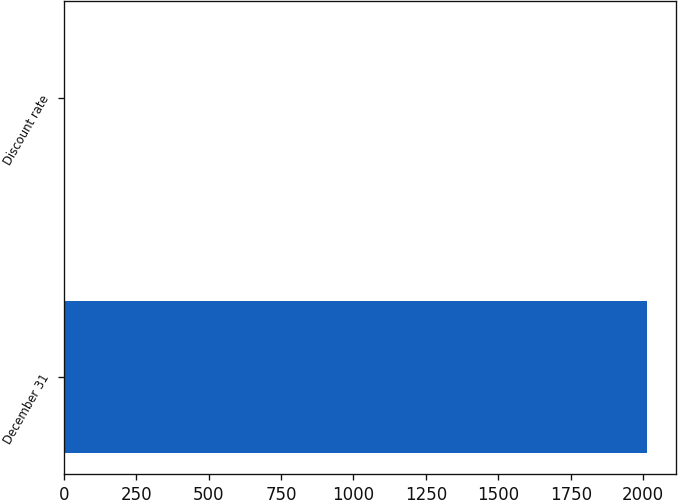Convert chart. <chart><loc_0><loc_0><loc_500><loc_500><bar_chart><fcel>December 31<fcel>Discount rate<nl><fcel>2014<fcel>3.7<nl></chart> 